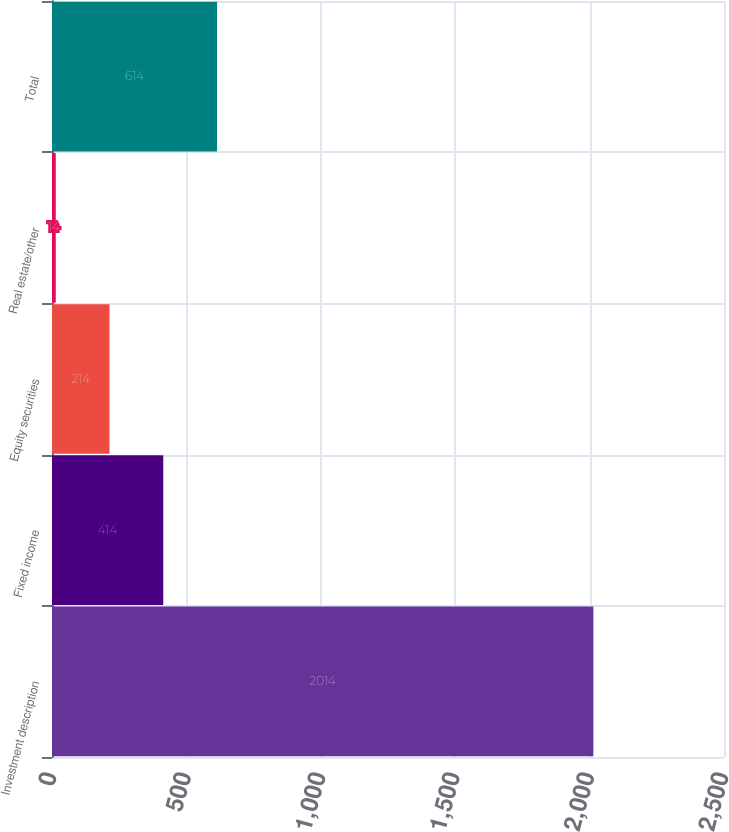<chart> <loc_0><loc_0><loc_500><loc_500><bar_chart><fcel>Investment description<fcel>Fixed income<fcel>Equity securities<fcel>Real estate/other<fcel>Total<nl><fcel>2014<fcel>414<fcel>214<fcel>14<fcel>614<nl></chart> 